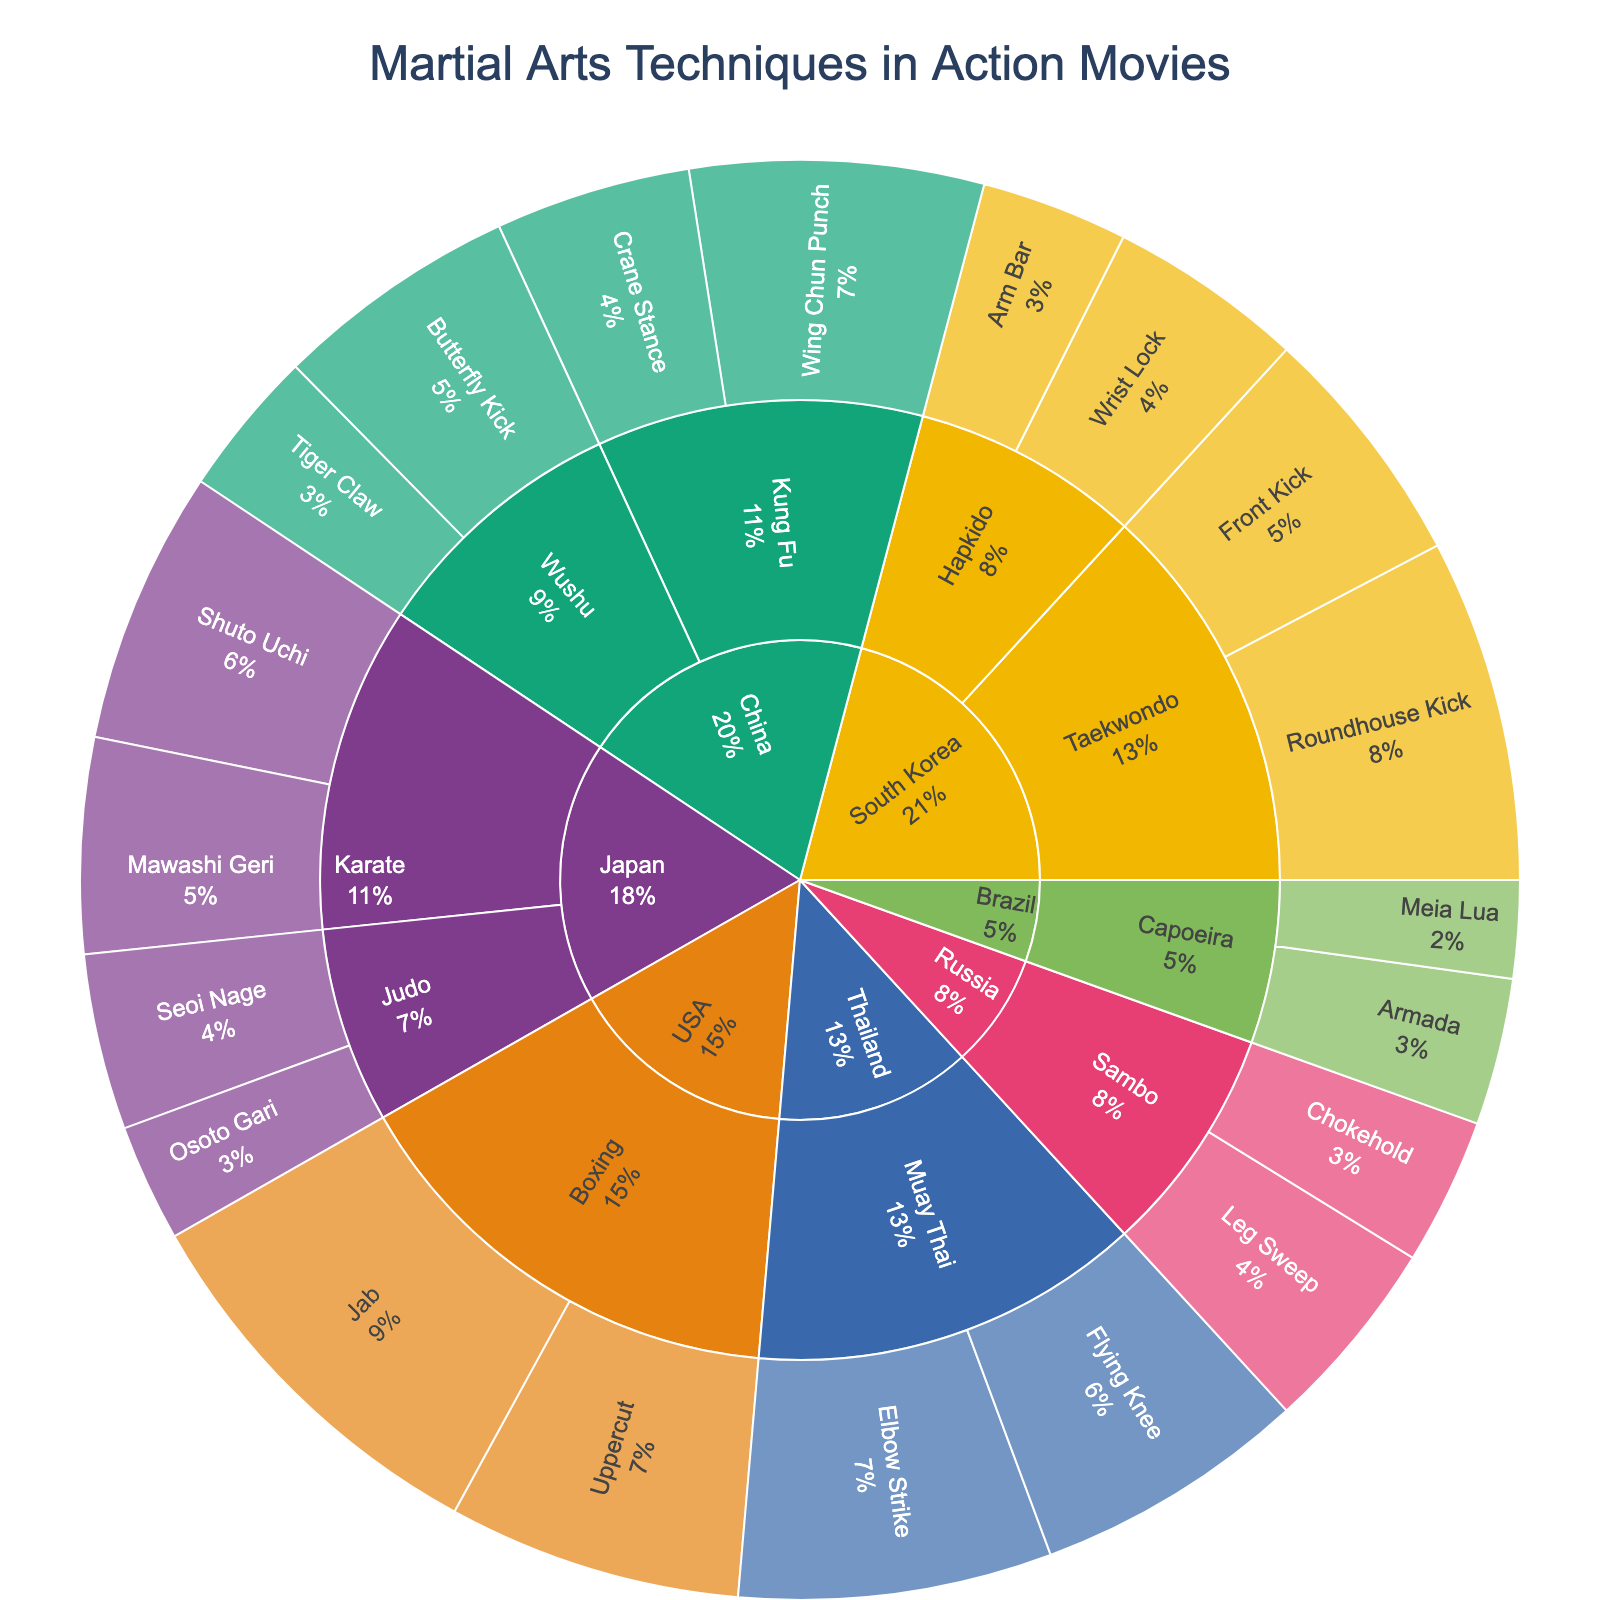What are the countries represented by different colors in the sunburst plot? The sunburst plot uses different colors to distinguish between martial arts origins. Each unique color corresponds to a different country.
Answer: South Korea, China, Japan, Thailand, Brazil, USA, Russia Which country has the highest frequency for any single technique? By examining the frequencies in the plot, the highest frequency for any single technique can be found.
Answer: USA (Jab, 40) How many martial arts styles are listed under South Korea? The plot shows different segments for South Korea. Count each unique style segment under this section.
Answer: 2 (Taekwondo, Hapkido) Which martial arts style has the highest accumulated frequency value in China? To answer this, sum the frequencies of techniques under each style in China and compare.
Answer: Kung Fu Between Muay Thai and Capoeira, which style has a higher total frequency? By summing the frequencies of each technique under Muay Thai and Capoeira, you can compare the totals.
Answer: Muay Thai (60 vs 25) What is the percentage distribution of techniques within Japanese martial arts styles? Calculate the percentage of each technique's frequency from the total frequency within Japanese martial arts styles. The percentages will then show the distribution.
Answer: Shuto Uchi: ~28.57%, Mawashi Geri: ~22.45%, Seoi Nage: ~18.37%, Osoto Gari: ~12.24% Which two techniques have the lowest frequency in the entire plot? Scan through the frequencies shown in the plot and identify the two with the lowest values.
Answer: Meia Lua (10) and Osoto Gari (12) How does the frequency of Russian techniques compare to Brazilian techniques? Compare the sum frequencies of all techniques for Russia versus Brazil.
Answer: Russia (35) vs Brazil (25) What martial arts technique is most frequently used in South Korean action movies? Check the South Korea section of the plot and identify the technique with the highest frequency.
Answer: Roundhouse Kick (35) Is the sum of frequencies for Taekwondo greater, equal to, or less than Hapkido in South Korea? Add the frequencies of techniques under Taekwondo and compare with the sum for Hapkido.
Answer: Greater (60 vs 35) 